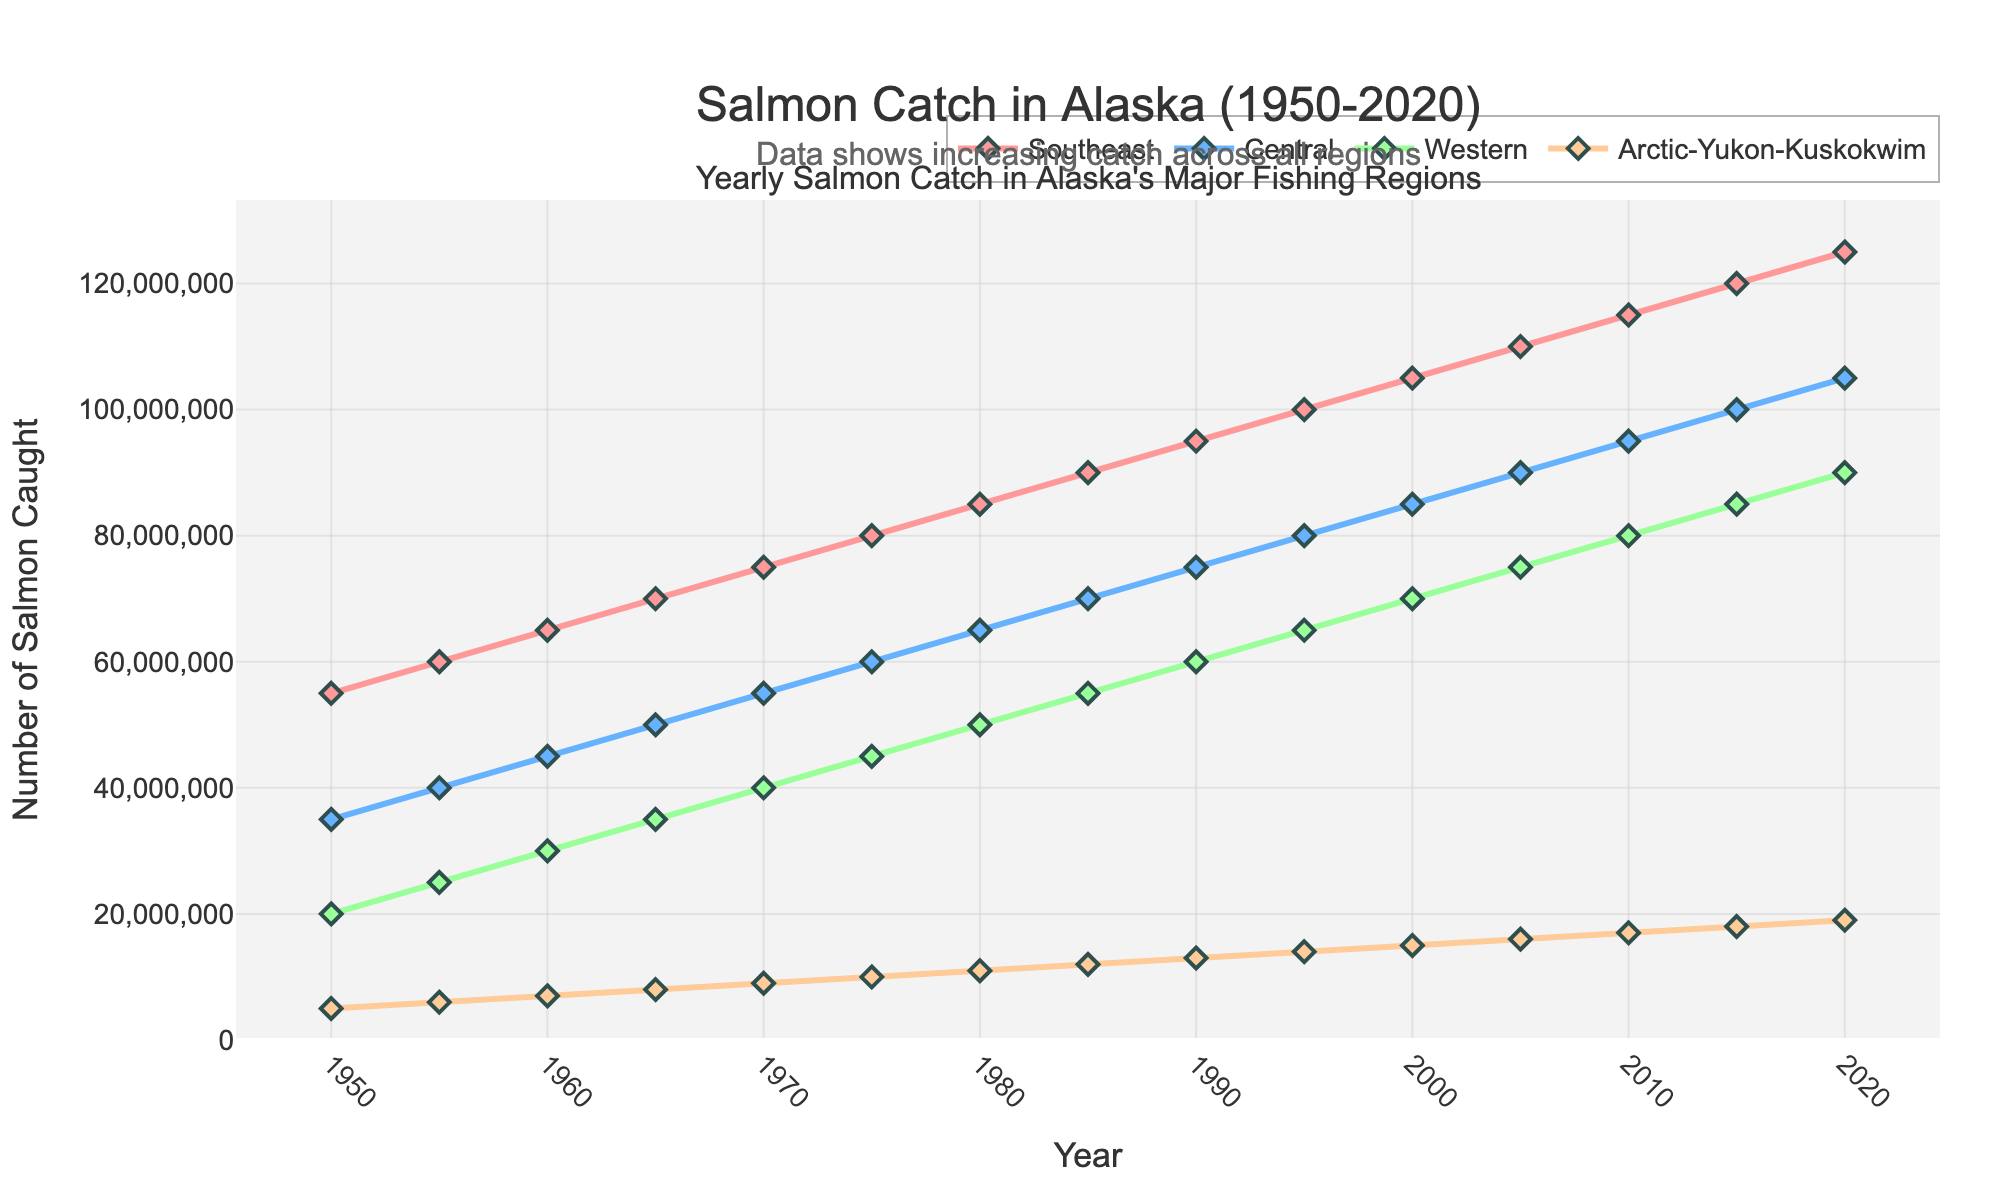What's the overall trend in the number of salmon caught in all major fishing regions? The chart shows that the number of salmon caught in all four regions (Southeast, Central, Western, Arctic-Yukon-Kuskokwim) has been steadily increasing from 1950 to 2020. For instance, in 1950, the Southeast region had 55 million, and by 2020, it reached 125 million. Similarly, other regions exhibit a similar trend.
Answer: Increasing Which region had the lowest number of salmon caught in 1950 and 2020? In 1950, the Arctic-Yukon-Kuskokwim region had the lowest number of salmon caught, which is around 5 million. By 2020, it still had the lowest number of 19 million compared to the other regions.
Answer: Arctic-Yukon-Kuskokwim By how much did the salmon catch in the Central region increase from 1950 to 2020? In 1950, the Central region had 35 million salmon caught, and by 2020, this number increased to 105 million. Therefore, the increase is 105 million - 35 million = 70 million salmon.
Answer: 70 million Which region had the highest number of salmon caught in 2005? The Southeast region had the highest number of salmon caught in 2005, with the figure around 110 million.
Answer: Southeast What was the difference in salmon catch between the Western and Central regions in 1990? In 1990, the Western region had 60 million salmon caught, and the Central region had 75 million. The difference is 75 million - 60 million = 15 million.
Answer: 15 million Which region had the steepest increase in salmon catch between 1950 and 2020? Visually, the Southeast region appears to have the steepest increase, starting at 55 million in 1950 and reaching 125 million by 2020. This increase of 70 million is the highest among the regions.
Answer: Southeast How does the number of salmon caught in the Western region compare to the Arctic-Yukon-Kuskokwim region in 1985? In 1985, the Western region had 55 million salmon caught, whereas the Arctic-Yukon-Kuskokwim region had 12 million. The Western region thus had significantly more.
Answer: Higher in Western What is the average number of salmon caught in the Southeast region from 1950 to 2020? First, sum up the data points in the Southeast from 1950 to 2020: 55 + 60 + 65 + 70 + 75 + 80 + 85 + 90 + 95 + 100 + 105 + 110 + 115 + 120 + 125 = 1375 million. There are 15 data points, so the average is 1375 / 15 = 91.67 million.
Answer: 91.67 million 